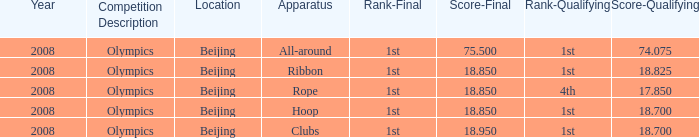075? 75.5. 